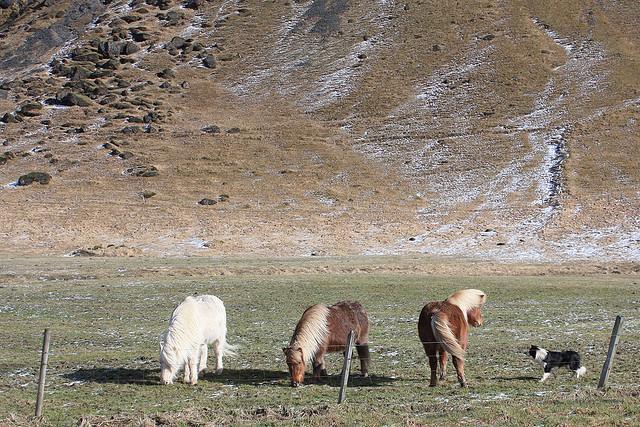How many horses?
Give a very brief answer. 3. How many brown horses are there?
Give a very brief answer. 2. How many horses are in the photo?
Give a very brief answer. 3. 